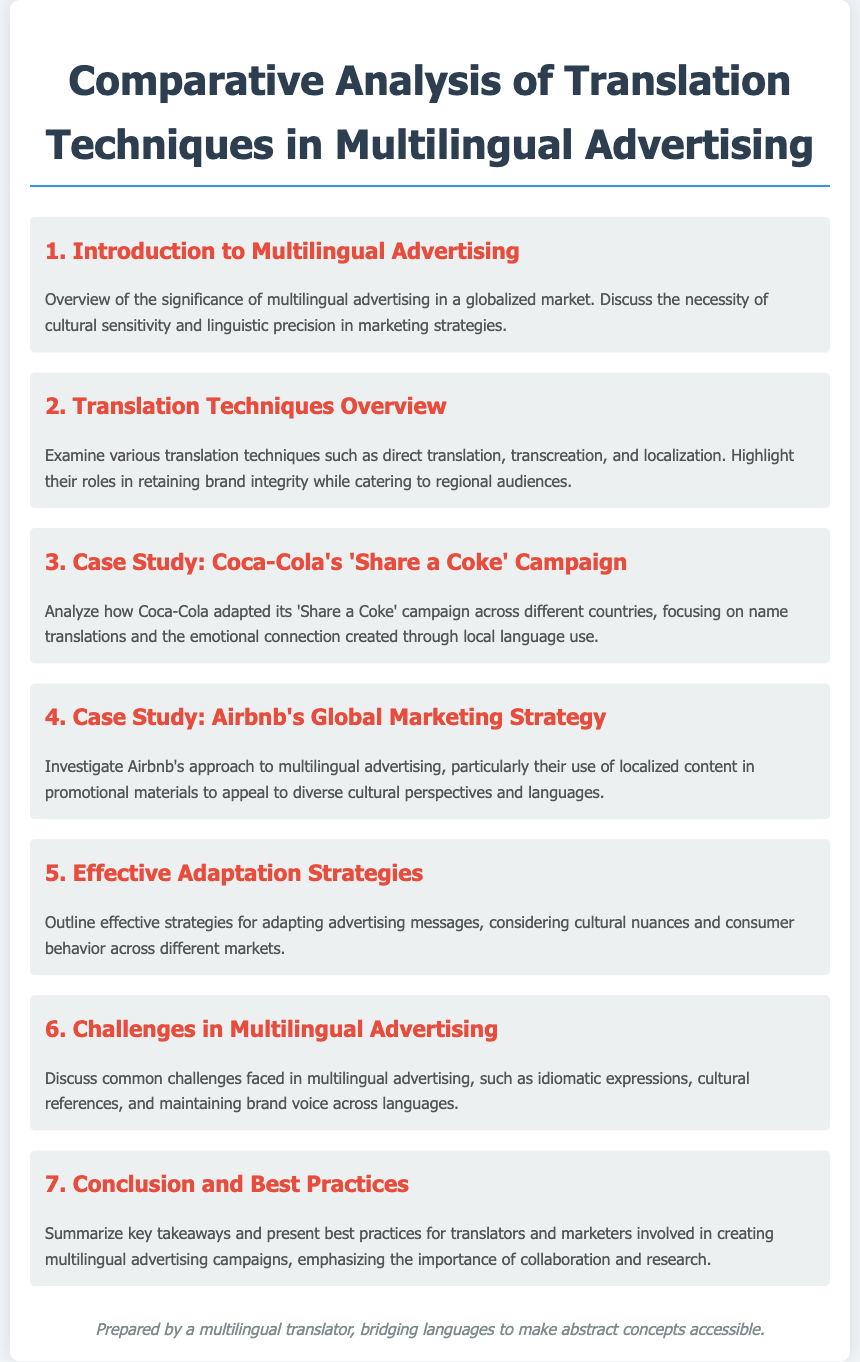What is the title of the document? The title summarizes the main topic of the document, which is focused on translation techniques in multilingual advertising.
Answer: Comparative Analysis of Translation Techniques in Multilingual Advertising What is the first agenda item? The first agenda item introduces the general concept of the document's focus.
Answer: Introduction to Multilingual Advertising Which company's campaign is analyzed in the third agenda item? The agenda specifies the company whose campaign is examined for its translation techniques.
Answer: Coca-Cola What is a technique discussed in the second agenda item? The second agenda item highlights specific methods used in translation relevant to advertising.
Answer: Transcreation What is the focus of the sixth agenda item? The sixth agenda item addresses the challenges faced in translation within advertising contexts.
Answer: Challenges in Multilingual Advertising How many case studies are presented in the document? The agenda lists the number of case studies highlighted in the analysis.
Answer: Two What does the last agenda item summarize? The last agenda item provides a conclusion, focusing on key takeaways and best practices derived from the earlier sections.
Answer: Conclusion and Best Practices 